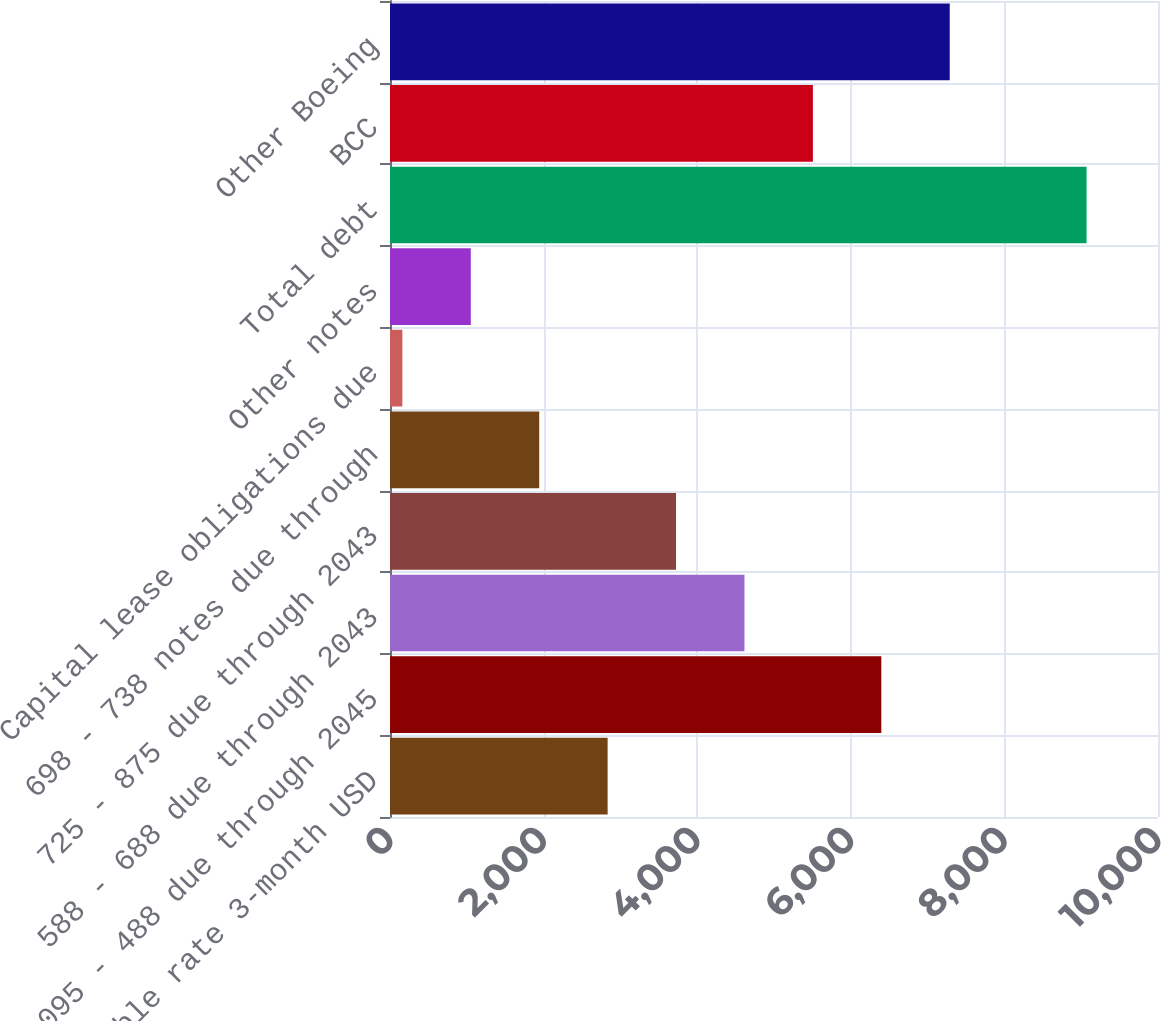Convert chart. <chart><loc_0><loc_0><loc_500><loc_500><bar_chart><fcel>Variable rate 3-month USD<fcel>095 - 488 due through 2045<fcel>588 - 688 due through 2043<fcel>725 - 875 due through 2043<fcel>698 - 738 notes due through<fcel>Capital lease obligations due<fcel>Other notes<fcel>Total debt<fcel>BCC<fcel>Other Boeing<nl><fcel>2833.7<fcel>6397.3<fcel>4615.5<fcel>3724.6<fcel>1942.8<fcel>161<fcel>1051.9<fcel>9070<fcel>5506.4<fcel>7288.2<nl></chart> 